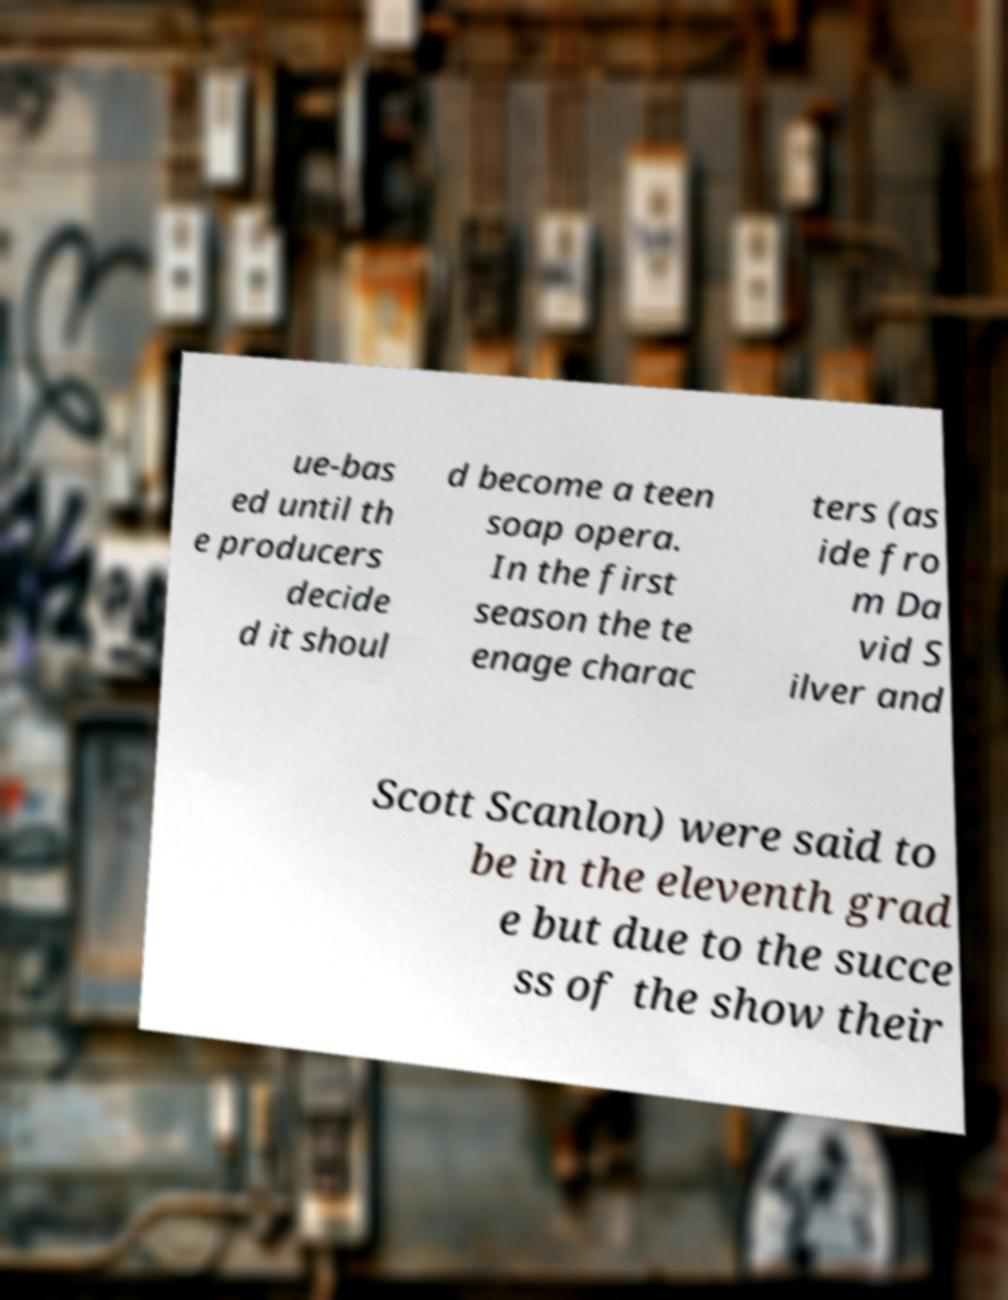There's text embedded in this image that I need extracted. Can you transcribe it verbatim? ue-bas ed until th e producers decide d it shoul d become a teen soap opera. In the first season the te enage charac ters (as ide fro m Da vid S ilver and Scott Scanlon) were said to be in the eleventh grad e but due to the succe ss of the show their 